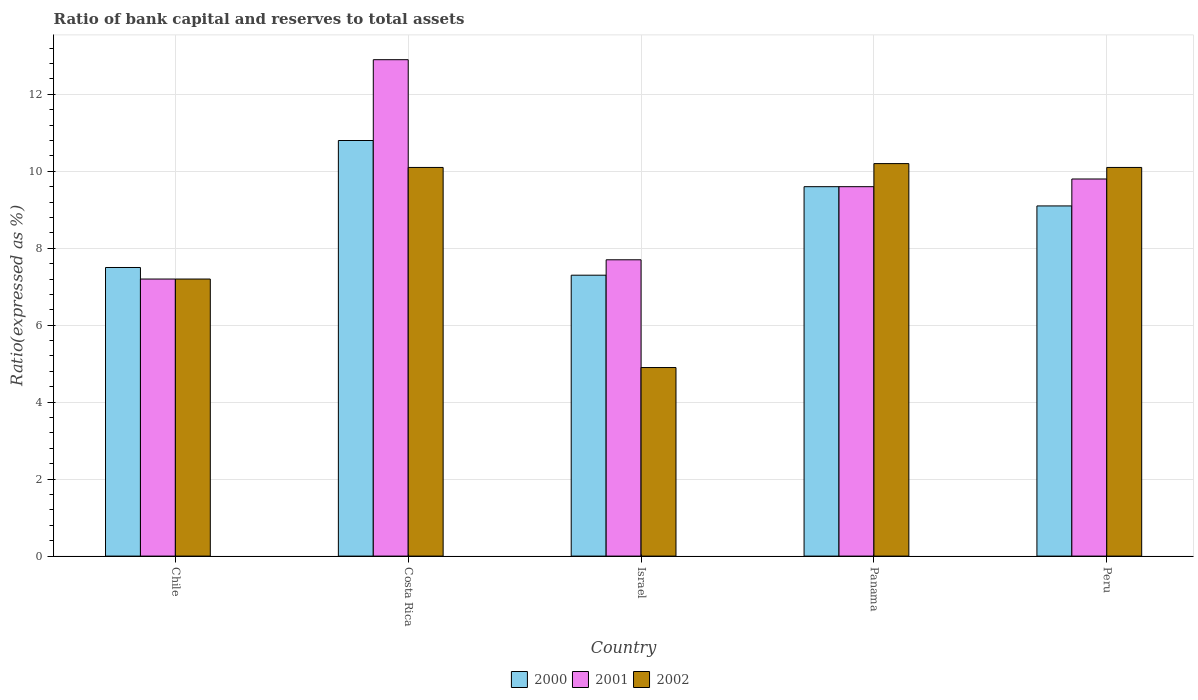Are the number of bars per tick equal to the number of legend labels?
Provide a short and direct response. Yes. What is the label of the 1st group of bars from the left?
Your answer should be very brief. Chile. What is the ratio of bank capital and reserves to total assets in 2002 in Panama?
Provide a short and direct response. 10.2. Across all countries, what is the maximum ratio of bank capital and reserves to total assets in 2002?
Offer a very short reply. 10.2. In which country was the ratio of bank capital and reserves to total assets in 2001 maximum?
Your answer should be compact. Costa Rica. What is the total ratio of bank capital and reserves to total assets in 2000 in the graph?
Your answer should be compact. 44.3. What is the difference between the ratio of bank capital and reserves to total assets in 2002 in Costa Rica and that in Israel?
Make the answer very short. 5.2. What is the average ratio of bank capital and reserves to total assets in 2001 per country?
Your answer should be compact. 9.44. What is the difference between the ratio of bank capital and reserves to total assets of/in 2000 and ratio of bank capital and reserves to total assets of/in 2002 in Israel?
Your response must be concise. 2.4. In how many countries, is the ratio of bank capital and reserves to total assets in 2000 greater than 2 %?
Provide a short and direct response. 5. What is the ratio of the ratio of bank capital and reserves to total assets in 2001 in Israel to that in Panama?
Provide a succinct answer. 0.8. Is the ratio of bank capital and reserves to total assets in 2001 in Chile less than that in Costa Rica?
Make the answer very short. Yes. What is the difference between the highest and the second highest ratio of bank capital and reserves to total assets in 2002?
Give a very brief answer. 0.1. What is the difference between the highest and the lowest ratio of bank capital and reserves to total assets in 2000?
Your answer should be very brief. 3.5. In how many countries, is the ratio of bank capital and reserves to total assets in 2002 greater than the average ratio of bank capital and reserves to total assets in 2002 taken over all countries?
Provide a succinct answer. 3. What does the 1st bar from the right in Israel represents?
Provide a short and direct response. 2002. Are all the bars in the graph horizontal?
Offer a terse response. No. What is the difference between two consecutive major ticks on the Y-axis?
Keep it short and to the point. 2. Does the graph contain grids?
Make the answer very short. Yes. Where does the legend appear in the graph?
Your answer should be very brief. Bottom center. How many legend labels are there?
Your answer should be very brief. 3. How are the legend labels stacked?
Your answer should be very brief. Horizontal. What is the title of the graph?
Offer a terse response. Ratio of bank capital and reserves to total assets. Does "2013" appear as one of the legend labels in the graph?
Give a very brief answer. No. What is the label or title of the X-axis?
Ensure brevity in your answer.  Country. What is the label or title of the Y-axis?
Provide a succinct answer. Ratio(expressed as %). What is the Ratio(expressed as %) in 2000 in Chile?
Ensure brevity in your answer.  7.5. What is the Ratio(expressed as %) of 2001 in Chile?
Ensure brevity in your answer.  7.2. What is the Ratio(expressed as %) in 2002 in Chile?
Your answer should be very brief. 7.2. What is the Ratio(expressed as %) of 2001 in Costa Rica?
Keep it short and to the point. 12.9. What is the Ratio(expressed as %) of 2002 in Costa Rica?
Ensure brevity in your answer.  10.1. What is the Ratio(expressed as %) in 2000 in Israel?
Your answer should be very brief. 7.3. What is the Ratio(expressed as %) of 2001 in Israel?
Make the answer very short. 7.7. What is the Ratio(expressed as %) of 2002 in Panama?
Your answer should be very brief. 10.2. What is the Ratio(expressed as %) of 2001 in Peru?
Ensure brevity in your answer.  9.8. What is the Ratio(expressed as %) of 2002 in Peru?
Give a very brief answer. 10.1. Across all countries, what is the maximum Ratio(expressed as %) in 2001?
Your answer should be compact. 12.9. Across all countries, what is the maximum Ratio(expressed as %) in 2002?
Offer a very short reply. 10.2. Across all countries, what is the minimum Ratio(expressed as %) of 2000?
Ensure brevity in your answer.  7.3. Across all countries, what is the minimum Ratio(expressed as %) in 2002?
Offer a very short reply. 4.9. What is the total Ratio(expressed as %) of 2000 in the graph?
Your response must be concise. 44.3. What is the total Ratio(expressed as %) in 2001 in the graph?
Offer a very short reply. 47.2. What is the total Ratio(expressed as %) in 2002 in the graph?
Your response must be concise. 42.5. What is the difference between the Ratio(expressed as %) of 2000 in Chile and that in Costa Rica?
Offer a very short reply. -3.3. What is the difference between the Ratio(expressed as %) of 2000 in Chile and that in Panama?
Offer a terse response. -2.1. What is the difference between the Ratio(expressed as %) in 2001 in Chile and that in Panama?
Your response must be concise. -2.4. What is the difference between the Ratio(expressed as %) of 2000 in Chile and that in Peru?
Make the answer very short. -1.6. What is the difference between the Ratio(expressed as %) of 2001 in Chile and that in Peru?
Your answer should be compact. -2.6. What is the difference between the Ratio(expressed as %) of 2002 in Chile and that in Peru?
Offer a very short reply. -2.9. What is the difference between the Ratio(expressed as %) in 2001 in Costa Rica and that in Israel?
Provide a short and direct response. 5.2. What is the difference between the Ratio(expressed as %) of 2001 in Costa Rica and that in Panama?
Offer a terse response. 3.3. What is the difference between the Ratio(expressed as %) in 2002 in Costa Rica and that in Panama?
Ensure brevity in your answer.  -0.1. What is the difference between the Ratio(expressed as %) in 2000 in Costa Rica and that in Peru?
Offer a very short reply. 1.7. What is the difference between the Ratio(expressed as %) of 2001 in Costa Rica and that in Peru?
Give a very brief answer. 3.1. What is the difference between the Ratio(expressed as %) of 2002 in Costa Rica and that in Peru?
Provide a succinct answer. 0. What is the difference between the Ratio(expressed as %) in 2001 in Israel and that in Panama?
Give a very brief answer. -1.9. What is the difference between the Ratio(expressed as %) of 2002 in Israel and that in Panama?
Your answer should be very brief. -5.3. What is the difference between the Ratio(expressed as %) in 2000 in Israel and that in Peru?
Keep it short and to the point. -1.8. What is the difference between the Ratio(expressed as %) of 2001 in Chile and the Ratio(expressed as %) of 2002 in Costa Rica?
Your answer should be compact. -2.9. What is the difference between the Ratio(expressed as %) in 2000 in Chile and the Ratio(expressed as %) in 2002 in Israel?
Your response must be concise. 2.6. What is the difference between the Ratio(expressed as %) in 2001 in Chile and the Ratio(expressed as %) in 2002 in Israel?
Provide a short and direct response. 2.3. What is the difference between the Ratio(expressed as %) of 2000 in Chile and the Ratio(expressed as %) of 2001 in Panama?
Your answer should be compact. -2.1. What is the difference between the Ratio(expressed as %) in 2000 in Chile and the Ratio(expressed as %) in 2002 in Peru?
Provide a succinct answer. -2.6. What is the difference between the Ratio(expressed as %) of 2000 in Costa Rica and the Ratio(expressed as %) of 2001 in Israel?
Provide a short and direct response. 3.1. What is the difference between the Ratio(expressed as %) in 2000 in Costa Rica and the Ratio(expressed as %) in 2002 in Israel?
Keep it short and to the point. 5.9. What is the difference between the Ratio(expressed as %) in 2001 in Costa Rica and the Ratio(expressed as %) in 2002 in Israel?
Ensure brevity in your answer.  8. What is the difference between the Ratio(expressed as %) in 2000 in Costa Rica and the Ratio(expressed as %) in 2001 in Panama?
Provide a short and direct response. 1.2. What is the difference between the Ratio(expressed as %) in 2000 in Costa Rica and the Ratio(expressed as %) in 2001 in Peru?
Provide a short and direct response. 1. What is the difference between the Ratio(expressed as %) of 2000 in Israel and the Ratio(expressed as %) of 2001 in Panama?
Your response must be concise. -2.3. What is the difference between the Ratio(expressed as %) of 2000 in Israel and the Ratio(expressed as %) of 2002 in Panama?
Offer a very short reply. -2.9. What is the difference between the Ratio(expressed as %) of 2000 in Israel and the Ratio(expressed as %) of 2002 in Peru?
Your answer should be compact. -2.8. What is the difference between the Ratio(expressed as %) in 2001 in Israel and the Ratio(expressed as %) in 2002 in Peru?
Offer a terse response. -2.4. What is the difference between the Ratio(expressed as %) of 2000 in Panama and the Ratio(expressed as %) of 2001 in Peru?
Make the answer very short. -0.2. What is the difference between the Ratio(expressed as %) in 2000 in Panama and the Ratio(expressed as %) in 2002 in Peru?
Provide a succinct answer. -0.5. What is the average Ratio(expressed as %) in 2000 per country?
Give a very brief answer. 8.86. What is the average Ratio(expressed as %) of 2001 per country?
Give a very brief answer. 9.44. What is the average Ratio(expressed as %) in 2002 per country?
Make the answer very short. 8.5. What is the difference between the Ratio(expressed as %) in 2000 and Ratio(expressed as %) in 2002 in Costa Rica?
Provide a short and direct response. 0.7. What is the difference between the Ratio(expressed as %) of 2001 and Ratio(expressed as %) of 2002 in Panama?
Ensure brevity in your answer.  -0.6. What is the difference between the Ratio(expressed as %) in 2001 and Ratio(expressed as %) in 2002 in Peru?
Keep it short and to the point. -0.3. What is the ratio of the Ratio(expressed as %) in 2000 in Chile to that in Costa Rica?
Your answer should be very brief. 0.69. What is the ratio of the Ratio(expressed as %) in 2001 in Chile to that in Costa Rica?
Make the answer very short. 0.56. What is the ratio of the Ratio(expressed as %) of 2002 in Chile to that in Costa Rica?
Offer a very short reply. 0.71. What is the ratio of the Ratio(expressed as %) in 2000 in Chile to that in Israel?
Provide a short and direct response. 1.03. What is the ratio of the Ratio(expressed as %) in 2001 in Chile to that in Israel?
Keep it short and to the point. 0.94. What is the ratio of the Ratio(expressed as %) of 2002 in Chile to that in Israel?
Provide a succinct answer. 1.47. What is the ratio of the Ratio(expressed as %) of 2000 in Chile to that in Panama?
Ensure brevity in your answer.  0.78. What is the ratio of the Ratio(expressed as %) of 2002 in Chile to that in Panama?
Ensure brevity in your answer.  0.71. What is the ratio of the Ratio(expressed as %) in 2000 in Chile to that in Peru?
Make the answer very short. 0.82. What is the ratio of the Ratio(expressed as %) in 2001 in Chile to that in Peru?
Offer a very short reply. 0.73. What is the ratio of the Ratio(expressed as %) of 2002 in Chile to that in Peru?
Provide a short and direct response. 0.71. What is the ratio of the Ratio(expressed as %) of 2000 in Costa Rica to that in Israel?
Offer a terse response. 1.48. What is the ratio of the Ratio(expressed as %) of 2001 in Costa Rica to that in Israel?
Offer a very short reply. 1.68. What is the ratio of the Ratio(expressed as %) in 2002 in Costa Rica to that in Israel?
Offer a terse response. 2.06. What is the ratio of the Ratio(expressed as %) of 2000 in Costa Rica to that in Panama?
Keep it short and to the point. 1.12. What is the ratio of the Ratio(expressed as %) of 2001 in Costa Rica to that in Panama?
Offer a very short reply. 1.34. What is the ratio of the Ratio(expressed as %) of 2002 in Costa Rica to that in Panama?
Make the answer very short. 0.99. What is the ratio of the Ratio(expressed as %) in 2000 in Costa Rica to that in Peru?
Your response must be concise. 1.19. What is the ratio of the Ratio(expressed as %) in 2001 in Costa Rica to that in Peru?
Your response must be concise. 1.32. What is the ratio of the Ratio(expressed as %) of 2000 in Israel to that in Panama?
Provide a short and direct response. 0.76. What is the ratio of the Ratio(expressed as %) in 2001 in Israel to that in Panama?
Your response must be concise. 0.8. What is the ratio of the Ratio(expressed as %) in 2002 in Israel to that in Panama?
Make the answer very short. 0.48. What is the ratio of the Ratio(expressed as %) of 2000 in Israel to that in Peru?
Your answer should be compact. 0.8. What is the ratio of the Ratio(expressed as %) in 2001 in Israel to that in Peru?
Give a very brief answer. 0.79. What is the ratio of the Ratio(expressed as %) in 2002 in Israel to that in Peru?
Provide a succinct answer. 0.49. What is the ratio of the Ratio(expressed as %) in 2000 in Panama to that in Peru?
Offer a very short reply. 1.05. What is the ratio of the Ratio(expressed as %) in 2001 in Panama to that in Peru?
Ensure brevity in your answer.  0.98. What is the ratio of the Ratio(expressed as %) in 2002 in Panama to that in Peru?
Your response must be concise. 1.01. What is the difference between the highest and the second highest Ratio(expressed as %) of 2001?
Keep it short and to the point. 3.1. What is the difference between the highest and the second highest Ratio(expressed as %) in 2002?
Provide a short and direct response. 0.1. What is the difference between the highest and the lowest Ratio(expressed as %) of 2001?
Provide a succinct answer. 5.7. 